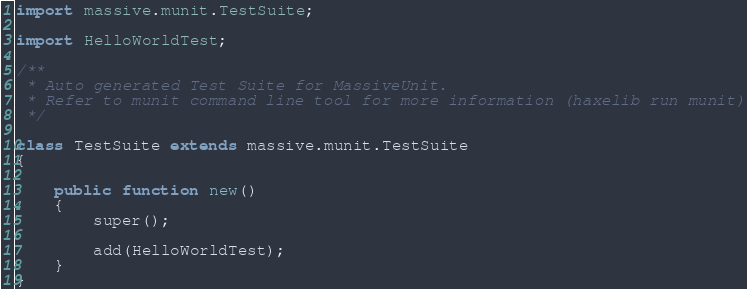<code> <loc_0><loc_0><loc_500><loc_500><_Haxe_>import massive.munit.TestSuite;

import HelloWorldTest;

/**
 * Auto generated Test Suite for MassiveUnit.
 * Refer to munit command line tool for more information (haxelib run munit)
 */

class TestSuite extends massive.munit.TestSuite
{		

	public function new()
	{
		super();

		add(HelloWorldTest);
	}
}
</code> 